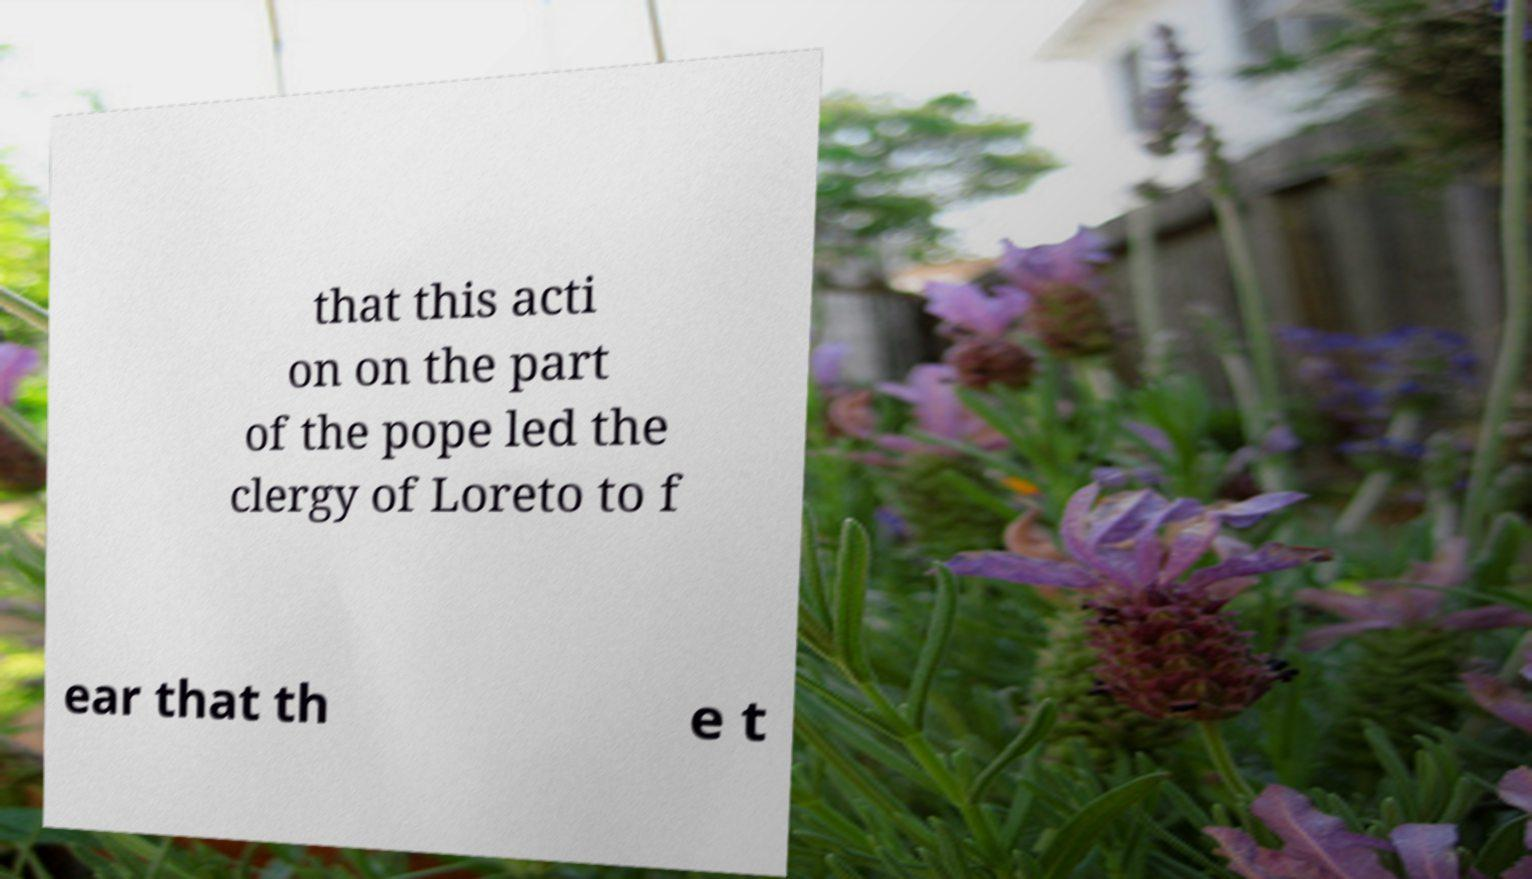What messages or text are displayed in this image? I need them in a readable, typed format. that this acti on on the part of the pope led the clergy of Loreto to f ear that th e t 